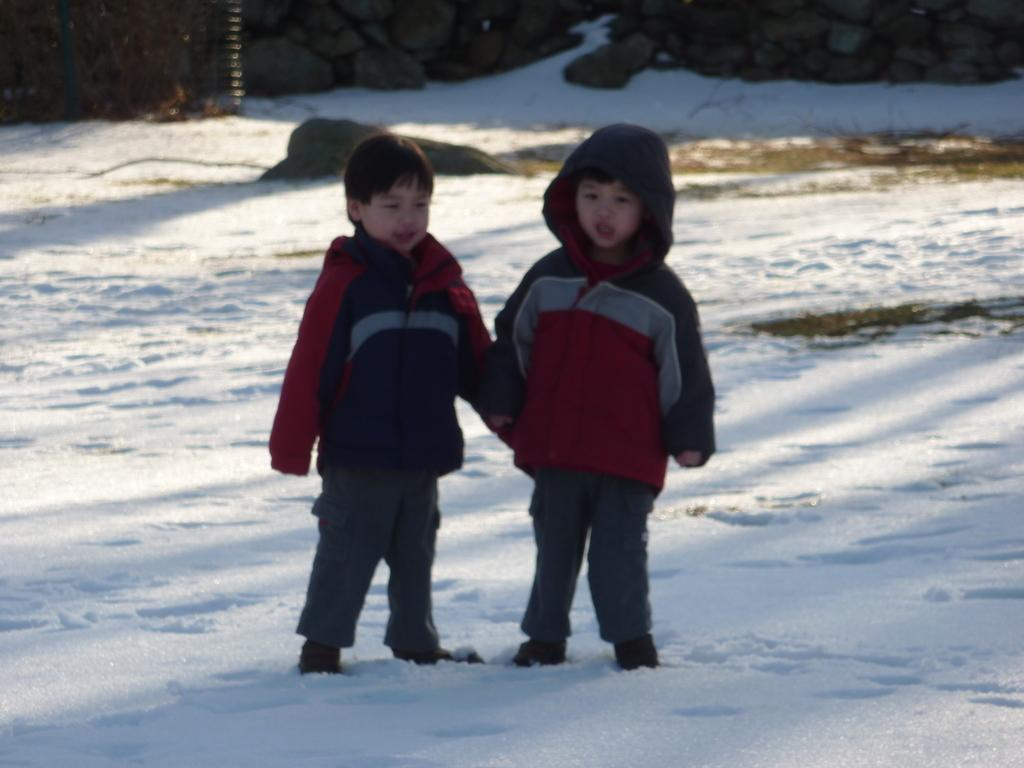How many children are in the image? There are two children in the image. What is the surface the children are standing on? The children are standing on the snow. What can be seen in the background of the image? There are rocks visible in the background of the image. What type of stew is being prepared in the image? There is no stew present in the image; it features two children standing on the snow with rocks visible in the background. 